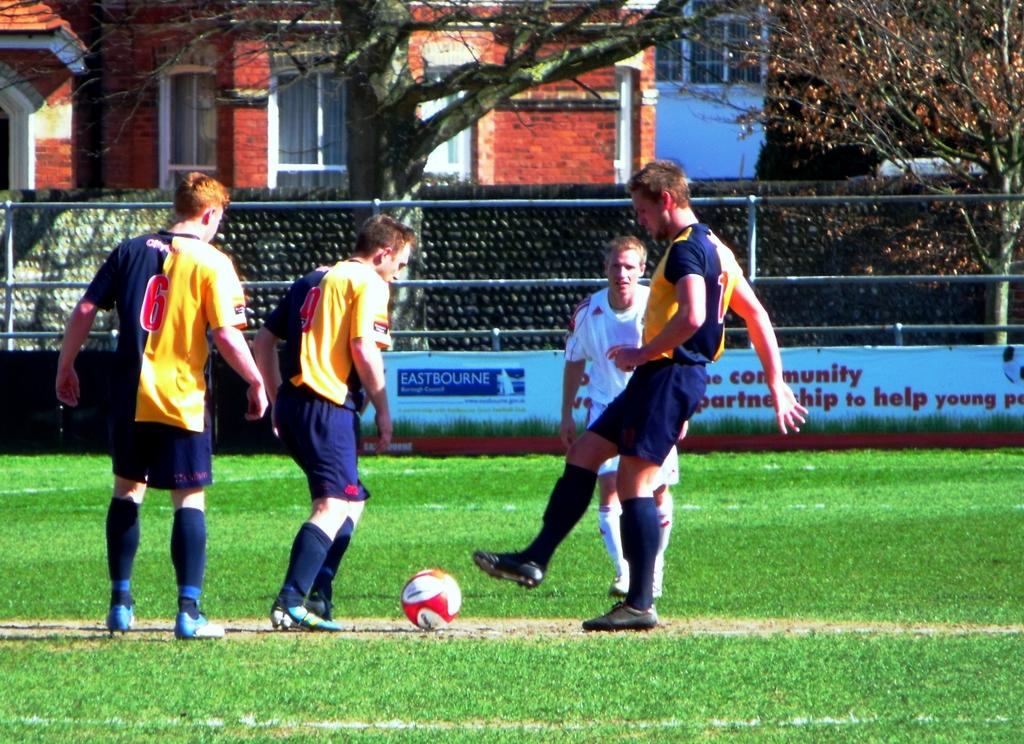<image>
Describe the image concisely. A few soccer players in front of a sponsorship sign reading Eastbourne. 